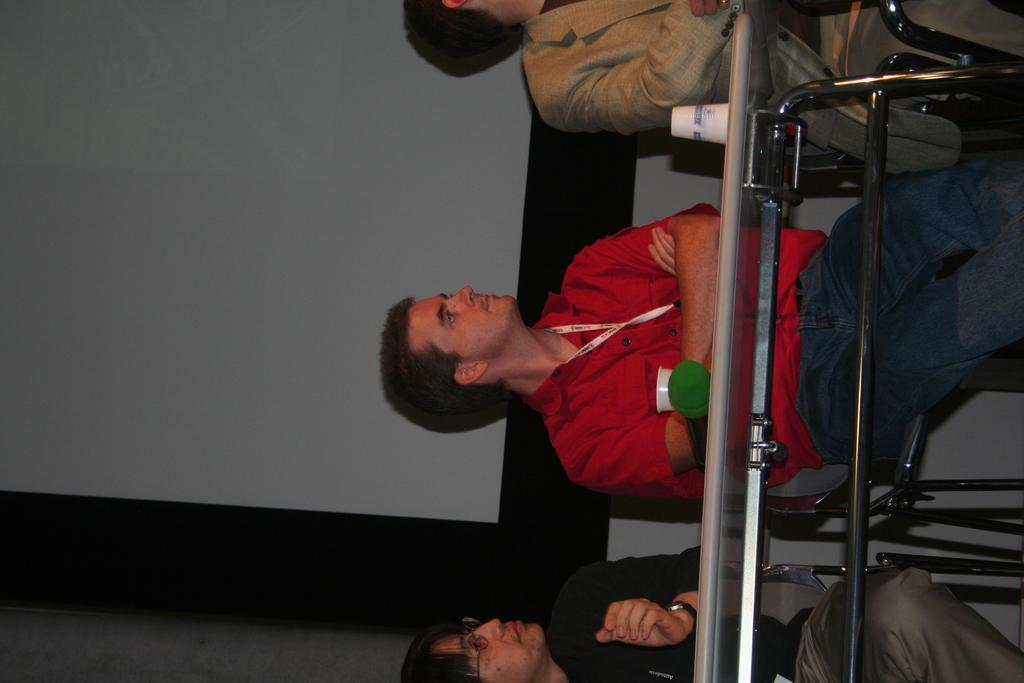How many people are in the image? There are three people in the image. What are the people doing in the image? The people are sitting on chairs in the image. Where are the chairs located in relation to the table? The chairs are behind the table in the image. What can be found on the table? There are cups and an object on the table in the image. What is visible in the background of the image? There appears to be a screen in the background of the image. What type of glove is being pulled by the person on the left in the image? There is no glove or person pulling a glove in the image; the people are sitting on chairs behind a table. 